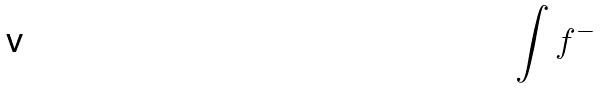<formula> <loc_0><loc_0><loc_500><loc_500>\int f ^ { - }</formula> 